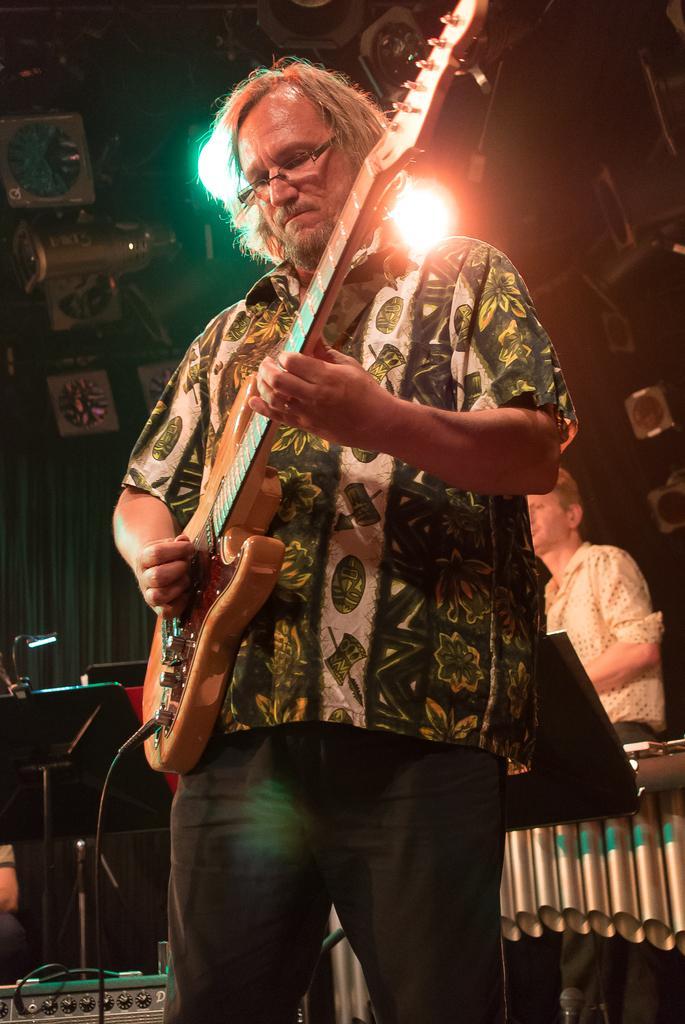In one or two sentences, can you explain what this image depicts? In this image I see a man who is holding a guitar and standing. In the background I see 2 lights and a person. 